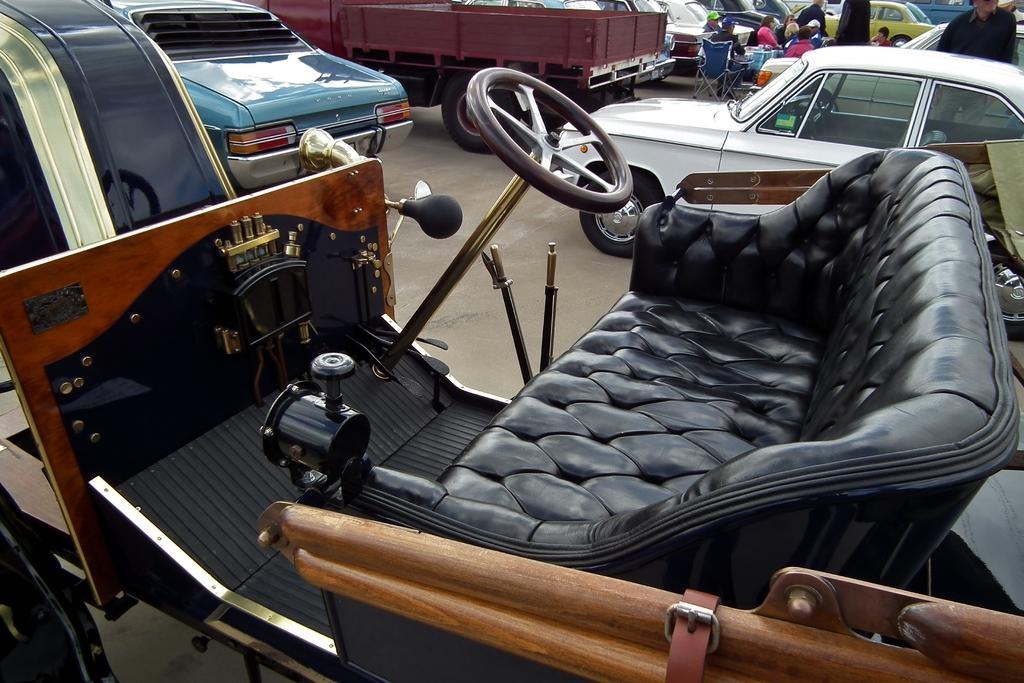What are the people in the image doing? The people in the image are sitting on chairs. Where are the chairs located in the image? The chairs are in the foreground of the image. Are there any other chairs visible in the image? Yes, there are people sitting on chairs in the background of the image. What type of powder is sprinkled on the chairs in the image? There is no powder visible on the chairs in the image. What flavor of jam is spread on the chairs in the image? There is no jam visible on the chairs in the image. 